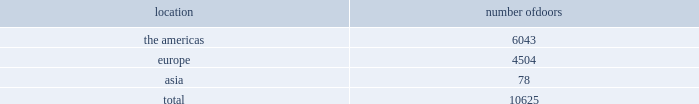The primary product offerings sold through our wholesale channels of distribution include menswear , womenswear , childrenswear , accessories , and home furnishings .
Our collection brands 2014 women 2019s ralph lauren collection and black label and men 2019s purple label and black label 2014 are distributed worldwide through a limited number of premier fashion retailers .
Department stores are our major wholesale customers in north america .
In latin america , our wholesale products are sold in department stores and specialty stores .
In europe , our wholesale sales are a varying mix of sales to both department stores and specialty stores , depending on the country .
We also distribute product to certain licensed stores operated by franchisees in europe and asia .
In addition , our club monaco products are distributed through select department stores and specialty stores in europe .
In japan , our wholesale products are distributed primarily through shop-within-shops at premier and top-tier department stores , and the mix of business is weighted to women 2019s and men's blue label .
In the greater china and southeast asia region , our wholesale products are sold at mid and top-tier department stores in china , thailand , and the philippines , and the mix of business is primarily weighted to men 2019s and women 2019s blue label .
We sell the majority of our excess and out-of-season products through secondary distribution channels worldwide , including our retail factory stores .
Worldwide distribution channels the table presents the number of doors by geographic location in which ralph lauren-branded products distributed by our wholesale segment were sold to consumers in our primary channels of distribution as of march 30 , 2013 : location number of .
In addition , chaps-branded products distributed by our wholesale segment were sold domestically through approximately 1200 doors as of march 30 , we have three key wholesale customers that generate significant sales volume .
For fiscal 2013 , these customers in the aggregate accounted for approximately 45% ( 45 % ) of our total wholesale revenues , with macy 2019s , inc .
( "macy's" ) representing approximately 25% ( 25 % ) of our total wholesale revenues .
Our products are sold primarily through our own sales forces .
Our wholesale segment maintains its primary showrooms in new york city .
In addition , we maintain regional showrooms in boston , milan , paris , london , munich , madrid , and stockholm .
Shop-within-shops .
As a critical element of our distribution to department stores , we and our licensing partners utilize shop-within-shops to enhance brand recognition , to permit more complete merchandising of our lines by the department stores , and to differentiate the presentation of our products .
Shop- within-shop fixed assets primarily include items such as customized freestanding fixtures , wall cases and components , decorative items , and flooring .
As of march 30 , 2013 , we had approximately 20000 shop-within-shops dedicated to our ralph lauren-branded wholesale products worldwide .
The size of our shop-within-shops ranges from approximately 100 to 7400 square feet .
We normally share in the cost of building-out these shop-within-shops with our wholesale customers .
Basic stock replenishment program .
Basic products such as knit shirts , chino pants , oxford cloth shirts , selected accessories , and home products can be ordered by our wholesale customers at any time through our basic stock replenishment programs .
We generally ship these products within two-to-five days of order receipt .
Our retail segment as of march 30 , 2013 , our retail segment consisted of 388 directly-operated freestanding stores worldwide , totaling approximately 3 million square feet , 494 concession-based shop-within-shops , and seven e-commerce websites .
The extension of our direct-to-consumer reach is one of our primary long-term strategic goals. .
What percentage of doors in the wholesale segment as of march 30 , 2013 where in the europe geography? 
Computations: (4504 / 10625)
Answer: 0.42391. The primary product offerings sold through our wholesale channels of distribution include menswear , womenswear , childrenswear , accessories , and home furnishings .
Our collection brands 2014 women 2019s ralph lauren collection and black label and men 2019s purple label and black label 2014 are distributed worldwide through a limited number of premier fashion retailers .
Department stores are our major wholesale customers in north america .
In latin america , our wholesale products are sold in department stores and specialty stores .
In europe , our wholesale sales are a varying mix of sales to both department stores and specialty stores , depending on the country .
We also distribute product to certain licensed stores operated by franchisees in europe and asia .
In addition , our club monaco products are distributed through select department stores and specialty stores in europe .
In japan , our wholesale products are distributed primarily through shop-within-shops at premier and top-tier department stores , and the mix of business is weighted to women 2019s and men's blue label .
In the greater china and southeast asia region , our wholesale products are sold at mid and top-tier department stores in china , thailand , and the philippines , and the mix of business is primarily weighted to men 2019s and women 2019s blue label .
We sell the majority of our excess and out-of-season products through secondary distribution channels worldwide , including our retail factory stores .
Worldwide distribution channels the table presents the number of doors by geographic location in which ralph lauren-branded products distributed by our wholesale segment were sold to consumers in our primary channels of distribution as of march 30 , 2013 : location number of .
In addition , chaps-branded products distributed by our wholesale segment were sold domestically through approximately 1200 doors as of march 30 , we have three key wholesale customers that generate significant sales volume .
For fiscal 2013 , these customers in the aggregate accounted for approximately 45% ( 45 % ) of our total wholesale revenues , with macy 2019s , inc .
( "macy's" ) representing approximately 25% ( 25 % ) of our total wholesale revenues .
Our products are sold primarily through our own sales forces .
Our wholesale segment maintains its primary showrooms in new york city .
In addition , we maintain regional showrooms in boston , milan , paris , london , munich , madrid , and stockholm .
Shop-within-shops .
As a critical element of our distribution to department stores , we and our licensing partners utilize shop-within-shops to enhance brand recognition , to permit more complete merchandising of our lines by the department stores , and to differentiate the presentation of our products .
Shop- within-shop fixed assets primarily include items such as customized freestanding fixtures , wall cases and components , decorative items , and flooring .
As of march 30 , 2013 , we had approximately 20000 shop-within-shops dedicated to our ralph lauren-branded wholesale products worldwide .
The size of our shop-within-shops ranges from approximately 100 to 7400 square feet .
We normally share in the cost of building-out these shop-within-shops with our wholesale customers .
Basic stock replenishment program .
Basic products such as knit shirts , chino pants , oxford cloth shirts , selected accessories , and home products can be ordered by our wholesale customers at any time through our basic stock replenishment programs .
We generally ship these products within two-to-five days of order receipt .
Our retail segment as of march 30 , 2013 , our retail segment consisted of 388 directly-operated freestanding stores worldwide , totaling approximately 3 million square feet , 494 concession-based shop-within-shops , and seven e-commerce websites .
The extension of our direct-to-consumer reach is one of our primary long-term strategic goals. .
What percentage of doors in the wholesale segment as of march 30 , 2013 where in the asia geography? 
Computations: (78 / 10625)
Answer: 0.00734. 